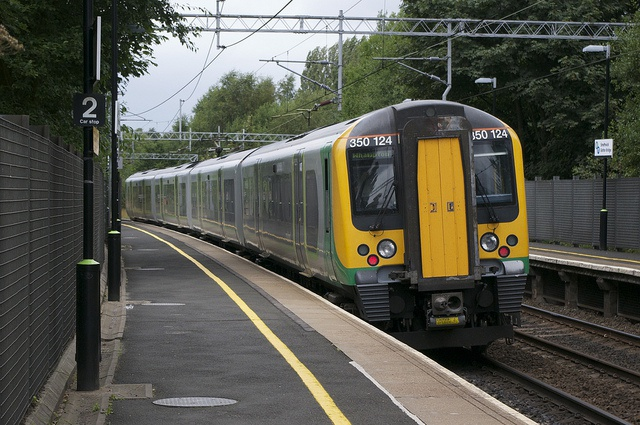Describe the objects in this image and their specific colors. I can see a train in black, gray, orange, and lightgray tones in this image. 